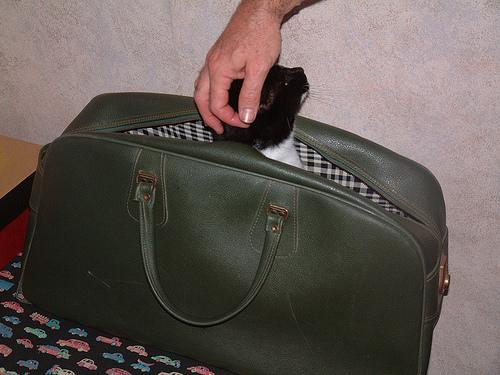What is the primary focus of this image and what is happening in the scene? The main focus of the image is a black and white kitten in a green bag. A hand is petting the kitten, and the bag is on a table with a table cloth that has little cars printed on it. Pinpoint the central object in the image and describe the scene around it. The focal object is a black and white kitten inside a green bag. Surrounding the bag is a table adorned with a tablecloth featuring car prints, and a human hand reaching in to stroke the kitten's head. Concisely identify the central character in the photo and describe their current engagement. The central character is a black and white kitten in a green bag, being petted by a human hand. The bag rests on a table adorned with a tablecloth showcasing a pattern of colorful automobiles. Briefly describe the scene in this picture and what is going on with the objects and people within it. The scene shows a black and white kitten sitting in a green bag on a table with a car-patterned tablecloth. A person's hand is petting the kitten, and various aspects of the bag and the surrounding environment are visible. Highlight the most notable aspect of this image and express what is happening in this moment. The key feature is a black and white kitten in a green bag being stroked by a human hand. The bag is on a table that has a tablecloth with a small car design. Identify the main subject in the image and explain their actions. The primary subject is a black and white kitten inside a green bag, receiving affection from a human hand that is petting it. The scene takes place on a table with a car-patterned tablecloth. Spotlight the predominant element in the image and narrate the ongoing actions. The dominant element is a black and white kitten nestled in a green bag on a table. A hand is petting the kitten, and the tablecloth has a motif of small, colorful automobiles. Point out the main subject of the picture, and mention any other notable features. The central subject is a black and white kitten inside a green bag. Additionally, there is a person's hand petting the kitten, a table with a tablecloth featuring car patterns, and various details about the bag, such as a handle and zipper. Examine the image and provide a brief account of the main subject and their environment. The main subject is a black and white kitten situated in a green bag. It is being patted by a hand, and the scene unfolds on a table covered with a tablecloth displaying an array of small, colorful cars. Choose the main topic of this image and give a quick summary of the situation. The central theme is a cat in a bag, with a black and white kitten being petted by a hand inside a green tote bag placed on a table with a colorful car-patterned tablecloth. 